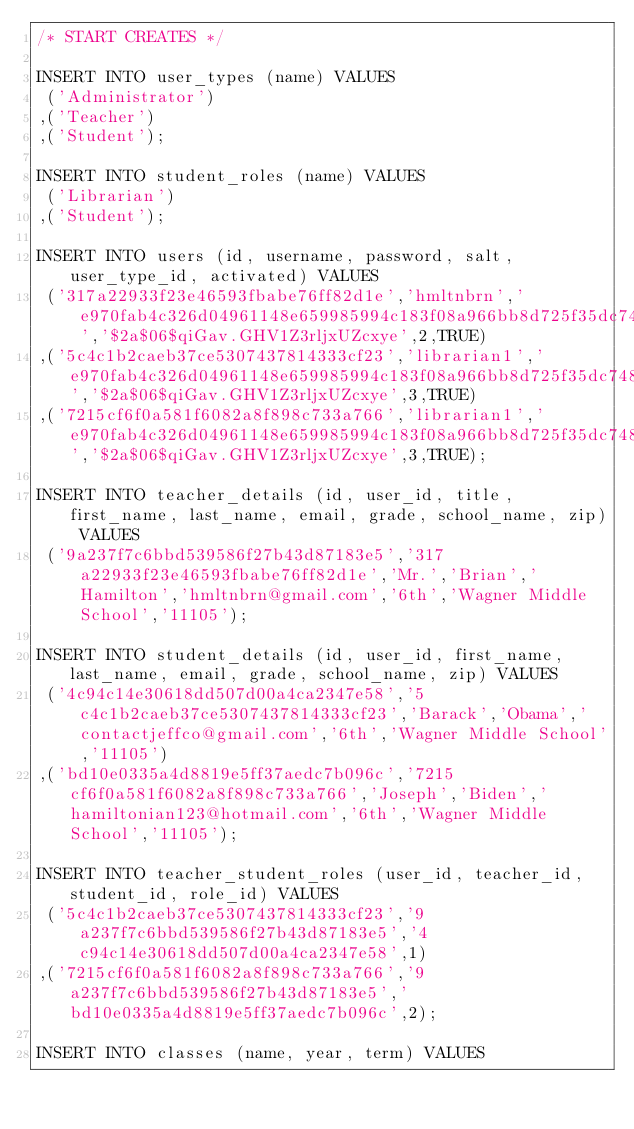Convert code to text. <code><loc_0><loc_0><loc_500><loc_500><_SQL_>/* START CREATES */

INSERT INTO user_types (name) VALUES
 ('Administrator')
,('Teacher')
,('Student');

INSERT INTO student_roles (name) VALUES
 ('Librarian')
,('Student');

INSERT INTO users (id, username, password, salt, user_type_id, activated) VALUES
 ('317a22933f23e46593fbabe76ff82d1e','hmltnbrn','e970fab4c326d04961148e659985994c183f08a966bb8d725f35dc748699f795','$2a$06$qiGav.GHV1Z3rljxUZcxye',2,TRUE)
,('5c4c1b2caeb37ce5307437814333cf23','librarian1','e970fab4c326d04961148e659985994c183f08a966bb8d725f35dc748699f795','$2a$06$qiGav.GHV1Z3rljxUZcxye',3,TRUE)
,('7215cf6f0a581f6082a8f898c733a766','librarian1','e970fab4c326d04961148e659985994c183f08a966bb8d725f35dc748699f795','$2a$06$qiGav.GHV1Z3rljxUZcxye',3,TRUE);

INSERT INTO teacher_details (id, user_id, title, first_name, last_name, email, grade, school_name, zip) VALUES
 ('9a237f7c6bbd539586f27b43d87183e5','317a22933f23e46593fbabe76ff82d1e','Mr.','Brian','Hamilton','hmltnbrn@gmail.com','6th','Wagner Middle School','11105');

INSERT INTO student_details (id, user_id, first_name, last_name, email, grade, school_name, zip) VALUES
 ('4c94c14e30618dd507d00a4ca2347e58','5c4c1b2caeb37ce5307437814333cf23','Barack','Obama','contactjeffco@gmail.com','6th','Wagner Middle School','11105')
,('bd10e0335a4d8819e5ff37aedc7b096c','7215cf6f0a581f6082a8f898c733a766','Joseph','Biden','hamiltonian123@hotmail.com','6th','Wagner Middle School','11105');

INSERT INTO teacher_student_roles (user_id, teacher_id, student_id, role_id) VALUES
 ('5c4c1b2caeb37ce5307437814333cf23','9a237f7c6bbd539586f27b43d87183e5','4c94c14e30618dd507d00a4ca2347e58',1)
,('7215cf6f0a581f6082a8f898c733a766','9a237f7c6bbd539586f27b43d87183e5','bd10e0335a4d8819e5ff37aedc7b096c',2);

INSERT INTO classes (name, year, term) VALUES</code> 